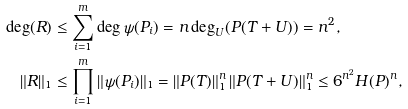<formula> <loc_0><loc_0><loc_500><loc_500>\deg ( R ) & \leq \sum _ { i = 1 } ^ { m } \deg \psi ( P _ { i } ) = n \deg _ { U } ( P ( T + U ) ) = n ^ { 2 } , \\ \| R \| _ { 1 } & \leq \prod _ { i = 1 } ^ { m } \| \psi ( P _ { i } ) \| _ { 1 } = \| P ( T ) \| _ { 1 } ^ { n } \, \| P ( T + U ) \| _ { 1 } ^ { n } \leq 6 ^ { n ^ { 2 } } H ( P ) ^ { n } ,</formula> 